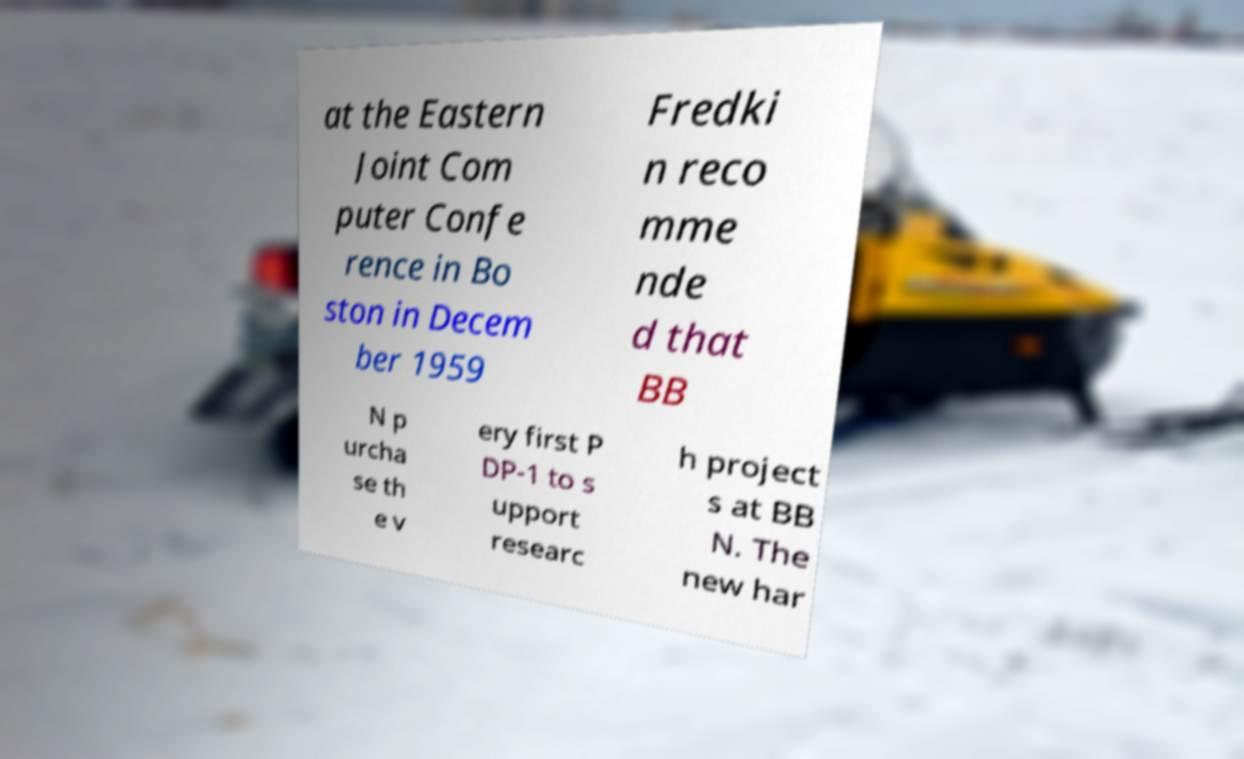Could you extract and type out the text from this image? at the Eastern Joint Com puter Confe rence in Bo ston in Decem ber 1959 Fredki n reco mme nde d that BB N p urcha se th e v ery first P DP-1 to s upport researc h project s at BB N. The new har 